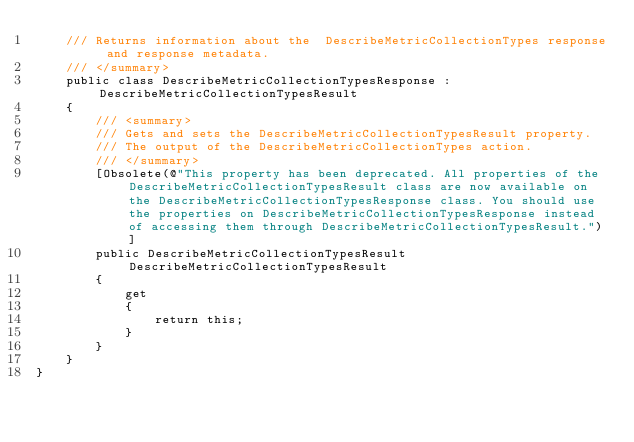Convert code to text. <code><loc_0><loc_0><loc_500><loc_500><_C#_>    /// Returns information about the  DescribeMetricCollectionTypes response and response metadata.
    /// </summary>
    public class DescribeMetricCollectionTypesResponse : DescribeMetricCollectionTypesResult
    {
        /// <summary>
        /// Gets and sets the DescribeMetricCollectionTypesResult property.
        /// The output of the DescribeMetricCollectionTypes action.
        /// </summary>
        [Obsolete(@"This property has been deprecated. All properties of the DescribeMetricCollectionTypesResult class are now available on the DescribeMetricCollectionTypesResponse class. You should use the properties on DescribeMetricCollectionTypesResponse instead of accessing them through DescribeMetricCollectionTypesResult.")]
        public DescribeMetricCollectionTypesResult DescribeMetricCollectionTypesResult
        {
            get
            {
                return this;
            }
        }
    }
}
    
</code> 